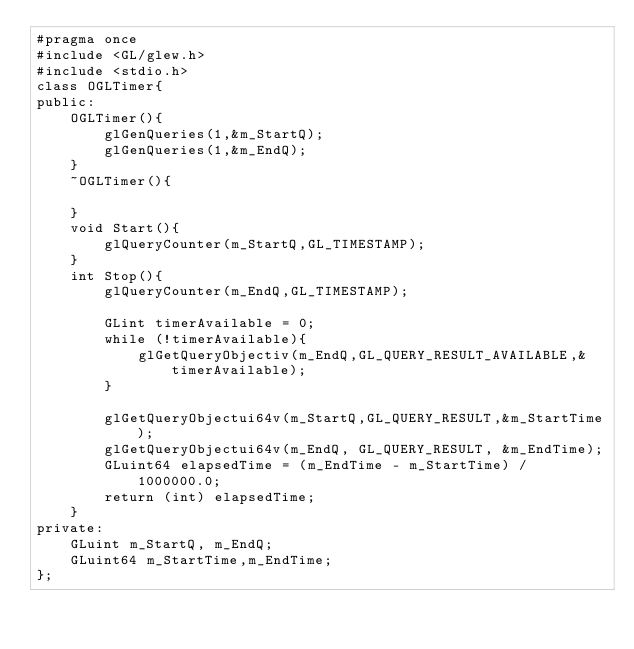<code> <loc_0><loc_0><loc_500><loc_500><_C_>#pragma once
#include <GL/glew.h>
#include <stdio.h>
class OGLTimer{
public:
	OGLTimer(){
		glGenQueries(1,&m_StartQ);
		glGenQueries(1,&m_EndQ);
	}
	~OGLTimer(){

	}
	void Start(){
		glQueryCounter(m_StartQ,GL_TIMESTAMP);
	}
	int Stop(){
		glQueryCounter(m_EndQ,GL_TIMESTAMP);

		GLint timerAvailable = 0;
		while (!timerAvailable){
			glGetQueryObjectiv(m_EndQ,GL_QUERY_RESULT_AVAILABLE,&timerAvailable);
		}

		glGetQueryObjectui64v(m_StartQ,GL_QUERY_RESULT,&m_StartTime);
		glGetQueryObjectui64v(m_EndQ, GL_QUERY_RESULT, &m_EndTime);
		GLuint64 elapsedTime = (m_EndTime - m_StartTime) / 1000000.0;
		return (int) elapsedTime;
	}
private:
	GLuint m_StartQ, m_EndQ;
	GLuint64 m_StartTime,m_EndTime;
};</code> 